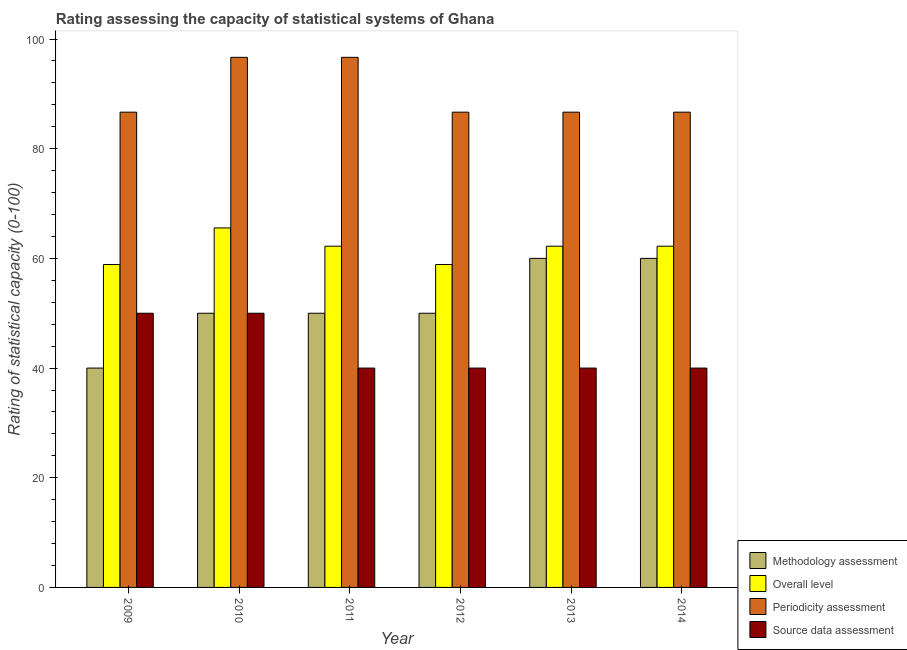How many groups of bars are there?
Make the answer very short. 6. Are the number of bars per tick equal to the number of legend labels?
Give a very brief answer. Yes. How many bars are there on the 2nd tick from the left?
Ensure brevity in your answer.  4. In how many cases, is the number of bars for a given year not equal to the number of legend labels?
Give a very brief answer. 0. What is the source data assessment rating in 2012?
Provide a short and direct response. 40. Across all years, what is the maximum overall level rating?
Provide a short and direct response. 65.56. Across all years, what is the minimum periodicity assessment rating?
Ensure brevity in your answer.  86.67. What is the total source data assessment rating in the graph?
Keep it short and to the point. 260. What is the difference between the methodology assessment rating in 2009 and that in 2011?
Give a very brief answer. -10. What is the difference between the overall level rating in 2013 and the methodology assessment rating in 2009?
Give a very brief answer. 3.33. What is the average periodicity assessment rating per year?
Your answer should be very brief. 90. What is the ratio of the methodology assessment rating in 2009 to that in 2013?
Provide a short and direct response. 0.67. Is the methodology assessment rating in 2009 less than that in 2012?
Ensure brevity in your answer.  Yes. What is the difference between the highest and the second highest source data assessment rating?
Offer a very short reply. 0. What is the difference between the highest and the lowest source data assessment rating?
Your response must be concise. 10. What does the 1st bar from the left in 2012 represents?
Ensure brevity in your answer.  Methodology assessment. What does the 1st bar from the right in 2011 represents?
Offer a very short reply. Source data assessment. Are all the bars in the graph horizontal?
Your response must be concise. No. How many years are there in the graph?
Give a very brief answer. 6. What is the difference between two consecutive major ticks on the Y-axis?
Provide a short and direct response. 20. How many legend labels are there?
Give a very brief answer. 4. What is the title of the graph?
Ensure brevity in your answer.  Rating assessing the capacity of statistical systems of Ghana. What is the label or title of the Y-axis?
Your answer should be compact. Rating of statistical capacity (0-100). What is the Rating of statistical capacity (0-100) in Methodology assessment in 2009?
Give a very brief answer. 40. What is the Rating of statistical capacity (0-100) in Overall level in 2009?
Your response must be concise. 58.89. What is the Rating of statistical capacity (0-100) in Periodicity assessment in 2009?
Provide a succinct answer. 86.67. What is the Rating of statistical capacity (0-100) in Source data assessment in 2009?
Provide a succinct answer. 50. What is the Rating of statistical capacity (0-100) in Methodology assessment in 2010?
Offer a terse response. 50. What is the Rating of statistical capacity (0-100) of Overall level in 2010?
Offer a terse response. 65.56. What is the Rating of statistical capacity (0-100) in Periodicity assessment in 2010?
Provide a succinct answer. 96.67. What is the Rating of statistical capacity (0-100) in Source data assessment in 2010?
Provide a succinct answer. 50. What is the Rating of statistical capacity (0-100) in Overall level in 2011?
Keep it short and to the point. 62.22. What is the Rating of statistical capacity (0-100) of Periodicity assessment in 2011?
Provide a succinct answer. 96.67. What is the Rating of statistical capacity (0-100) of Methodology assessment in 2012?
Make the answer very short. 50. What is the Rating of statistical capacity (0-100) of Overall level in 2012?
Provide a short and direct response. 58.89. What is the Rating of statistical capacity (0-100) of Periodicity assessment in 2012?
Make the answer very short. 86.67. What is the Rating of statistical capacity (0-100) in Source data assessment in 2012?
Give a very brief answer. 40. What is the Rating of statistical capacity (0-100) of Methodology assessment in 2013?
Provide a short and direct response. 60. What is the Rating of statistical capacity (0-100) of Overall level in 2013?
Ensure brevity in your answer.  62.22. What is the Rating of statistical capacity (0-100) of Periodicity assessment in 2013?
Make the answer very short. 86.67. What is the Rating of statistical capacity (0-100) of Source data assessment in 2013?
Provide a succinct answer. 40. What is the Rating of statistical capacity (0-100) in Methodology assessment in 2014?
Your answer should be very brief. 60. What is the Rating of statistical capacity (0-100) in Overall level in 2014?
Your answer should be compact. 62.22. What is the Rating of statistical capacity (0-100) of Periodicity assessment in 2014?
Offer a terse response. 86.67. What is the Rating of statistical capacity (0-100) in Source data assessment in 2014?
Provide a succinct answer. 40. Across all years, what is the maximum Rating of statistical capacity (0-100) in Overall level?
Offer a very short reply. 65.56. Across all years, what is the maximum Rating of statistical capacity (0-100) in Periodicity assessment?
Provide a succinct answer. 96.67. Across all years, what is the maximum Rating of statistical capacity (0-100) of Source data assessment?
Provide a succinct answer. 50. Across all years, what is the minimum Rating of statistical capacity (0-100) in Overall level?
Give a very brief answer. 58.89. Across all years, what is the minimum Rating of statistical capacity (0-100) in Periodicity assessment?
Give a very brief answer. 86.67. What is the total Rating of statistical capacity (0-100) in Methodology assessment in the graph?
Provide a short and direct response. 310. What is the total Rating of statistical capacity (0-100) of Overall level in the graph?
Ensure brevity in your answer.  370. What is the total Rating of statistical capacity (0-100) in Periodicity assessment in the graph?
Make the answer very short. 540. What is the total Rating of statistical capacity (0-100) of Source data assessment in the graph?
Your response must be concise. 260. What is the difference between the Rating of statistical capacity (0-100) of Methodology assessment in 2009 and that in 2010?
Keep it short and to the point. -10. What is the difference between the Rating of statistical capacity (0-100) in Overall level in 2009 and that in 2010?
Give a very brief answer. -6.67. What is the difference between the Rating of statistical capacity (0-100) of Periodicity assessment in 2009 and that in 2010?
Give a very brief answer. -10. What is the difference between the Rating of statistical capacity (0-100) of Source data assessment in 2009 and that in 2010?
Offer a terse response. 0. What is the difference between the Rating of statistical capacity (0-100) in Methodology assessment in 2009 and that in 2011?
Keep it short and to the point. -10. What is the difference between the Rating of statistical capacity (0-100) in Periodicity assessment in 2009 and that in 2012?
Offer a terse response. 0. What is the difference between the Rating of statistical capacity (0-100) of Source data assessment in 2009 and that in 2012?
Provide a short and direct response. 10. What is the difference between the Rating of statistical capacity (0-100) of Overall level in 2009 and that in 2013?
Your answer should be compact. -3.33. What is the difference between the Rating of statistical capacity (0-100) in Source data assessment in 2009 and that in 2013?
Your answer should be very brief. 10. What is the difference between the Rating of statistical capacity (0-100) in Methodology assessment in 2009 and that in 2014?
Keep it short and to the point. -20. What is the difference between the Rating of statistical capacity (0-100) in Overall level in 2009 and that in 2014?
Offer a very short reply. -3.33. What is the difference between the Rating of statistical capacity (0-100) in Source data assessment in 2009 and that in 2014?
Provide a short and direct response. 10. What is the difference between the Rating of statistical capacity (0-100) in Periodicity assessment in 2010 and that in 2011?
Ensure brevity in your answer.  0. What is the difference between the Rating of statistical capacity (0-100) in Overall level in 2010 and that in 2012?
Provide a succinct answer. 6.67. What is the difference between the Rating of statistical capacity (0-100) in Periodicity assessment in 2010 and that in 2012?
Give a very brief answer. 10. What is the difference between the Rating of statistical capacity (0-100) in Methodology assessment in 2010 and that in 2013?
Provide a short and direct response. -10. What is the difference between the Rating of statistical capacity (0-100) in Overall level in 2010 and that in 2013?
Your answer should be very brief. 3.33. What is the difference between the Rating of statistical capacity (0-100) in Methodology assessment in 2010 and that in 2014?
Your answer should be very brief. -10. What is the difference between the Rating of statistical capacity (0-100) in Overall level in 2010 and that in 2014?
Make the answer very short. 3.33. What is the difference between the Rating of statistical capacity (0-100) of Methodology assessment in 2011 and that in 2012?
Make the answer very short. 0. What is the difference between the Rating of statistical capacity (0-100) of Periodicity assessment in 2011 and that in 2012?
Ensure brevity in your answer.  10. What is the difference between the Rating of statistical capacity (0-100) in Source data assessment in 2011 and that in 2012?
Provide a succinct answer. 0. What is the difference between the Rating of statistical capacity (0-100) in Overall level in 2011 and that in 2013?
Offer a very short reply. 0. What is the difference between the Rating of statistical capacity (0-100) in Periodicity assessment in 2011 and that in 2013?
Give a very brief answer. 10. What is the difference between the Rating of statistical capacity (0-100) of Source data assessment in 2011 and that in 2014?
Give a very brief answer. 0. What is the difference between the Rating of statistical capacity (0-100) of Periodicity assessment in 2012 and that in 2013?
Offer a terse response. 0. What is the difference between the Rating of statistical capacity (0-100) in Methodology assessment in 2012 and that in 2014?
Give a very brief answer. -10. What is the difference between the Rating of statistical capacity (0-100) in Overall level in 2012 and that in 2014?
Give a very brief answer. -3.33. What is the difference between the Rating of statistical capacity (0-100) in Source data assessment in 2012 and that in 2014?
Provide a short and direct response. 0. What is the difference between the Rating of statistical capacity (0-100) in Periodicity assessment in 2013 and that in 2014?
Make the answer very short. 0. What is the difference between the Rating of statistical capacity (0-100) of Methodology assessment in 2009 and the Rating of statistical capacity (0-100) of Overall level in 2010?
Ensure brevity in your answer.  -25.56. What is the difference between the Rating of statistical capacity (0-100) of Methodology assessment in 2009 and the Rating of statistical capacity (0-100) of Periodicity assessment in 2010?
Keep it short and to the point. -56.67. What is the difference between the Rating of statistical capacity (0-100) in Overall level in 2009 and the Rating of statistical capacity (0-100) in Periodicity assessment in 2010?
Your answer should be compact. -37.78. What is the difference between the Rating of statistical capacity (0-100) in Overall level in 2009 and the Rating of statistical capacity (0-100) in Source data assessment in 2010?
Your answer should be compact. 8.89. What is the difference between the Rating of statistical capacity (0-100) of Periodicity assessment in 2009 and the Rating of statistical capacity (0-100) of Source data assessment in 2010?
Make the answer very short. 36.67. What is the difference between the Rating of statistical capacity (0-100) of Methodology assessment in 2009 and the Rating of statistical capacity (0-100) of Overall level in 2011?
Give a very brief answer. -22.22. What is the difference between the Rating of statistical capacity (0-100) in Methodology assessment in 2009 and the Rating of statistical capacity (0-100) in Periodicity assessment in 2011?
Your response must be concise. -56.67. What is the difference between the Rating of statistical capacity (0-100) in Overall level in 2009 and the Rating of statistical capacity (0-100) in Periodicity assessment in 2011?
Give a very brief answer. -37.78. What is the difference between the Rating of statistical capacity (0-100) in Overall level in 2009 and the Rating of statistical capacity (0-100) in Source data assessment in 2011?
Give a very brief answer. 18.89. What is the difference between the Rating of statistical capacity (0-100) of Periodicity assessment in 2009 and the Rating of statistical capacity (0-100) of Source data assessment in 2011?
Keep it short and to the point. 46.67. What is the difference between the Rating of statistical capacity (0-100) in Methodology assessment in 2009 and the Rating of statistical capacity (0-100) in Overall level in 2012?
Your answer should be compact. -18.89. What is the difference between the Rating of statistical capacity (0-100) of Methodology assessment in 2009 and the Rating of statistical capacity (0-100) of Periodicity assessment in 2012?
Ensure brevity in your answer.  -46.67. What is the difference between the Rating of statistical capacity (0-100) of Overall level in 2009 and the Rating of statistical capacity (0-100) of Periodicity assessment in 2012?
Make the answer very short. -27.78. What is the difference between the Rating of statistical capacity (0-100) of Overall level in 2009 and the Rating of statistical capacity (0-100) of Source data assessment in 2012?
Keep it short and to the point. 18.89. What is the difference between the Rating of statistical capacity (0-100) in Periodicity assessment in 2009 and the Rating of statistical capacity (0-100) in Source data assessment in 2012?
Provide a short and direct response. 46.67. What is the difference between the Rating of statistical capacity (0-100) of Methodology assessment in 2009 and the Rating of statistical capacity (0-100) of Overall level in 2013?
Make the answer very short. -22.22. What is the difference between the Rating of statistical capacity (0-100) of Methodology assessment in 2009 and the Rating of statistical capacity (0-100) of Periodicity assessment in 2013?
Keep it short and to the point. -46.67. What is the difference between the Rating of statistical capacity (0-100) in Overall level in 2009 and the Rating of statistical capacity (0-100) in Periodicity assessment in 2013?
Your answer should be compact. -27.78. What is the difference between the Rating of statistical capacity (0-100) in Overall level in 2009 and the Rating of statistical capacity (0-100) in Source data assessment in 2013?
Your answer should be very brief. 18.89. What is the difference between the Rating of statistical capacity (0-100) of Periodicity assessment in 2009 and the Rating of statistical capacity (0-100) of Source data assessment in 2013?
Your response must be concise. 46.67. What is the difference between the Rating of statistical capacity (0-100) of Methodology assessment in 2009 and the Rating of statistical capacity (0-100) of Overall level in 2014?
Offer a very short reply. -22.22. What is the difference between the Rating of statistical capacity (0-100) of Methodology assessment in 2009 and the Rating of statistical capacity (0-100) of Periodicity assessment in 2014?
Provide a short and direct response. -46.67. What is the difference between the Rating of statistical capacity (0-100) of Methodology assessment in 2009 and the Rating of statistical capacity (0-100) of Source data assessment in 2014?
Your answer should be compact. 0. What is the difference between the Rating of statistical capacity (0-100) in Overall level in 2009 and the Rating of statistical capacity (0-100) in Periodicity assessment in 2014?
Your answer should be very brief. -27.78. What is the difference between the Rating of statistical capacity (0-100) in Overall level in 2009 and the Rating of statistical capacity (0-100) in Source data assessment in 2014?
Provide a short and direct response. 18.89. What is the difference between the Rating of statistical capacity (0-100) of Periodicity assessment in 2009 and the Rating of statistical capacity (0-100) of Source data assessment in 2014?
Provide a succinct answer. 46.67. What is the difference between the Rating of statistical capacity (0-100) in Methodology assessment in 2010 and the Rating of statistical capacity (0-100) in Overall level in 2011?
Keep it short and to the point. -12.22. What is the difference between the Rating of statistical capacity (0-100) of Methodology assessment in 2010 and the Rating of statistical capacity (0-100) of Periodicity assessment in 2011?
Your answer should be compact. -46.67. What is the difference between the Rating of statistical capacity (0-100) in Overall level in 2010 and the Rating of statistical capacity (0-100) in Periodicity assessment in 2011?
Your answer should be compact. -31.11. What is the difference between the Rating of statistical capacity (0-100) in Overall level in 2010 and the Rating of statistical capacity (0-100) in Source data assessment in 2011?
Offer a very short reply. 25.56. What is the difference between the Rating of statistical capacity (0-100) in Periodicity assessment in 2010 and the Rating of statistical capacity (0-100) in Source data assessment in 2011?
Your answer should be very brief. 56.67. What is the difference between the Rating of statistical capacity (0-100) in Methodology assessment in 2010 and the Rating of statistical capacity (0-100) in Overall level in 2012?
Keep it short and to the point. -8.89. What is the difference between the Rating of statistical capacity (0-100) of Methodology assessment in 2010 and the Rating of statistical capacity (0-100) of Periodicity assessment in 2012?
Give a very brief answer. -36.67. What is the difference between the Rating of statistical capacity (0-100) in Methodology assessment in 2010 and the Rating of statistical capacity (0-100) in Source data assessment in 2012?
Your response must be concise. 10. What is the difference between the Rating of statistical capacity (0-100) in Overall level in 2010 and the Rating of statistical capacity (0-100) in Periodicity assessment in 2012?
Provide a short and direct response. -21.11. What is the difference between the Rating of statistical capacity (0-100) of Overall level in 2010 and the Rating of statistical capacity (0-100) of Source data assessment in 2012?
Ensure brevity in your answer.  25.56. What is the difference between the Rating of statistical capacity (0-100) in Periodicity assessment in 2010 and the Rating of statistical capacity (0-100) in Source data assessment in 2012?
Provide a succinct answer. 56.67. What is the difference between the Rating of statistical capacity (0-100) in Methodology assessment in 2010 and the Rating of statistical capacity (0-100) in Overall level in 2013?
Give a very brief answer. -12.22. What is the difference between the Rating of statistical capacity (0-100) of Methodology assessment in 2010 and the Rating of statistical capacity (0-100) of Periodicity assessment in 2013?
Give a very brief answer. -36.67. What is the difference between the Rating of statistical capacity (0-100) in Overall level in 2010 and the Rating of statistical capacity (0-100) in Periodicity assessment in 2013?
Give a very brief answer. -21.11. What is the difference between the Rating of statistical capacity (0-100) of Overall level in 2010 and the Rating of statistical capacity (0-100) of Source data assessment in 2013?
Your answer should be compact. 25.56. What is the difference between the Rating of statistical capacity (0-100) of Periodicity assessment in 2010 and the Rating of statistical capacity (0-100) of Source data assessment in 2013?
Your response must be concise. 56.67. What is the difference between the Rating of statistical capacity (0-100) in Methodology assessment in 2010 and the Rating of statistical capacity (0-100) in Overall level in 2014?
Keep it short and to the point. -12.22. What is the difference between the Rating of statistical capacity (0-100) in Methodology assessment in 2010 and the Rating of statistical capacity (0-100) in Periodicity assessment in 2014?
Your answer should be compact. -36.67. What is the difference between the Rating of statistical capacity (0-100) of Overall level in 2010 and the Rating of statistical capacity (0-100) of Periodicity assessment in 2014?
Make the answer very short. -21.11. What is the difference between the Rating of statistical capacity (0-100) in Overall level in 2010 and the Rating of statistical capacity (0-100) in Source data assessment in 2014?
Offer a very short reply. 25.56. What is the difference between the Rating of statistical capacity (0-100) of Periodicity assessment in 2010 and the Rating of statistical capacity (0-100) of Source data assessment in 2014?
Your response must be concise. 56.67. What is the difference between the Rating of statistical capacity (0-100) of Methodology assessment in 2011 and the Rating of statistical capacity (0-100) of Overall level in 2012?
Give a very brief answer. -8.89. What is the difference between the Rating of statistical capacity (0-100) in Methodology assessment in 2011 and the Rating of statistical capacity (0-100) in Periodicity assessment in 2012?
Provide a short and direct response. -36.67. What is the difference between the Rating of statistical capacity (0-100) in Methodology assessment in 2011 and the Rating of statistical capacity (0-100) in Source data assessment in 2012?
Offer a very short reply. 10. What is the difference between the Rating of statistical capacity (0-100) of Overall level in 2011 and the Rating of statistical capacity (0-100) of Periodicity assessment in 2012?
Your response must be concise. -24.44. What is the difference between the Rating of statistical capacity (0-100) of Overall level in 2011 and the Rating of statistical capacity (0-100) of Source data assessment in 2012?
Offer a very short reply. 22.22. What is the difference between the Rating of statistical capacity (0-100) of Periodicity assessment in 2011 and the Rating of statistical capacity (0-100) of Source data assessment in 2012?
Ensure brevity in your answer.  56.67. What is the difference between the Rating of statistical capacity (0-100) of Methodology assessment in 2011 and the Rating of statistical capacity (0-100) of Overall level in 2013?
Offer a very short reply. -12.22. What is the difference between the Rating of statistical capacity (0-100) of Methodology assessment in 2011 and the Rating of statistical capacity (0-100) of Periodicity assessment in 2013?
Your response must be concise. -36.67. What is the difference between the Rating of statistical capacity (0-100) of Overall level in 2011 and the Rating of statistical capacity (0-100) of Periodicity assessment in 2013?
Give a very brief answer. -24.44. What is the difference between the Rating of statistical capacity (0-100) of Overall level in 2011 and the Rating of statistical capacity (0-100) of Source data assessment in 2013?
Offer a terse response. 22.22. What is the difference between the Rating of statistical capacity (0-100) in Periodicity assessment in 2011 and the Rating of statistical capacity (0-100) in Source data assessment in 2013?
Provide a short and direct response. 56.67. What is the difference between the Rating of statistical capacity (0-100) in Methodology assessment in 2011 and the Rating of statistical capacity (0-100) in Overall level in 2014?
Make the answer very short. -12.22. What is the difference between the Rating of statistical capacity (0-100) of Methodology assessment in 2011 and the Rating of statistical capacity (0-100) of Periodicity assessment in 2014?
Your response must be concise. -36.67. What is the difference between the Rating of statistical capacity (0-100) of Overall level in 2011 and the Rating of statistical capacity (0-100) of Periodicity assessment in 2014?
Make the answer very short. -24.44. What is the difference between the Rating of statistical capacity (0-100) of Overall level in 2011 and the Rating of statistical capacity (0-100) of Source data assessment in 2014?
Your answer should be very brief. 22.22. What is the difference between the Rating of statistical capacity (0-100) in Periodicity assessment in 2011 and the Rating of statistical capacity (0-100) in Source data assessment in 2014?
Your answer should be very brief. 56.67. What is the difference between the Rating of statistical capacity (0-100) in Methodology assessment in 2012 and the Rating of statistical capacity (0-100) in Overall level in 2013?
Keep it short and to the point. -12.22. What is the difference between the Rating of statistical capacity (0-100) of Methodology assessment in 2012 and the Rating of statistical capacity (0-100) of Periodicity assessment in 2013?
Offer a very short reply. -36.67. What is the difference between the Rating of statistical capacity (0-100) in Methodology assessment in 2012 and the Rating of statistical capacity (0-100) in Source data assessment in 2013?
Your response must be concise. 10. What is the difference between the Rating of statistical capacity (0-100) of Overall level in 2012 and the Rating of statistical capacity (0-100) of Periodicity assessment in 2013?
Make the answer very short. -27.78. What is the difference between the Rating of statistical capacity (0-100) in Overall level in 2012 and the Rating of statistical capacity (0-100) in Source data assessment in 2013?
Keep it short and to the point. 18.89. What is the difference between the Rating of statistical capacity (0-100) of Periodicity assessment in 2012 and the Rating of statistical capacity (0-100) of Source data assessment in 2013?
Your answer should be very brief. 46.67. What is the difference between the Rating of statistical capacity (0-100) of Methodology assessment in 2012 and the Rating of statistical capacity (0-100) of Overall level in 2014?
Your answer should be compact. -12.22. What is the difference between the Rating of statistical capacity (0-100) of Methodology assessment in 2012 and the Rating of statistical capacity (0-100) of Periodicity assessment in 2014?
Offer a terse response. -36.67. What is the difference between the Rating of statistical capacity (0-100) of Overall level in 2012 and the Rating of statistical capacity (0-100) of Periodicity assessment in 2014?
Provide a short and direct response. -27.78. What is the difference between the Rating of statistical capacity (0-100) in Overall level in 2012 and the Rating of statistical capacity (0-100) in Source data assessment in 2014?
Your answer should be very brief. 18.89. What is the difference between the Rating of statistical capacity (0-100) in Periodicity assessment in 2012 and the Rating of statistical capacity (0-100) in Source data assessment in 2014?
Your answer should be compact. 46.67. What is the difference between the Rating of statistical capacity (0-100) of Methodology assessment in 2013 and the Rating of statistical capacity (0-100) of Overall level in 2014?
Your answer should be compact. -2.22. What is the difference between the Rating of statistical capacity (0-100) of Methodology assessment in 2013 and the Rating of statistical capacity (0-100) of Periodicity assessment in 2014?
Your answer should be compact. -26.67. What is the difference between the Rating of statistical capacity (0-100) of Overall level in 2013 and the Rating of statistical capacity (0-100) of Periodicity assessment in 2014?
Keep it short and to the point. -24.44. What is the difference between the Rating of statistical capacity (0-100) in Overall level in 2013 and the Rating of statistical capacity (0-100) in Source data assessment in 2014?
Offer a very short reply. 22.22. What is the difference between the Rating of statistical capacity (0-100) in Periodicity assessment in 2013 and the Rating of statistical capacity (0-100) in Source data assessment in 2014?
Your response must be concise. 46.67. What is the average Rating of statistical capacity (0-100) of Methodology assessment per year?
Make the answer very short. 51.67. What is the average Rating of statistical capacity (0-100) of Overall level per year?
Your answer should be very brief. 61.67. What is the average Rating of statistical capacity (0-100) in Periodicity assessment per year?
Your response must be concise. 90. What is the average Rating of statistical capacity (0-100) in Source data assessment per year?
Make the answer very short. 43.33. In the year 2009, what is the difference between the Rating of statistical capacity (0-100) in Methodology assessment and Rating of statistical capacity (0-100) in Overall level?
Offer a terse response. -18.89. In the year 2009, what is the difference between the Rating of statistical capacity (0-100) in Methodology assessment and Rating of statistical capacity (0-100) in Periodicity assessment?
Ensure brevity in your answer.  -46.67. In the year 2009, what is the difference between the Rating of statistical capacity (0-100) of Methodology assessment and Rating of statistical capacity (0-100) of Source data assessment?
Provide a succinct answer. -10. In the year 2009, what is the difference between the Rating of statistical capacity (0-100) of Overall level and Rating of statistical capacity (0-100) of Periodicity assessment?
Ensure brevity in your answer.  -27.78. In the year 2009, what is the difference between the Rating of statistical capacity (0-100) of Overall level and Rating of statistical capacity (0-100) of Source data assessment?
Make the answer very short. 8.89. In the year 2009, what is the difference between the Rating of statistical capacity (0-100) of Periodicity assessment and Rating of statistical capacity (0-100) of Source data assessment?
Offer a terse response. 36.67. In the year 2010, what is the difference between the Rating of statistical capacity (0-100) of Methodology assessment and Rating of statistical capacity (0-100) of Overall level?
Give a very brief answer. -15.56. In the year 2010, what is the difference between the Rating of statistical capacity (0-100) of Methodology assessment and Rating of statistical capacity (0-100) of Periodicity assessment?
Keep it short and to the point. -46.67. In the year 2010, what is the difference between the Rating of statistical capacity (0-100) of Overall level and Rating of statistical capacity (0-100) of Periodicity assessment?
Your answer should be compact. -31.11. In the year 2010, what is the difference between the Rating of statistical capacity (0-100) in Overall level and Rating of statistical capacity (0-100) in Source data assessment?
Your response must be concise. 15.56. In the year 2010, what is the difference between the Rating of statistical capacity (0-100) of Periodicity assessment and Rating of statistical capacity (0-100) of Source data assessment?
Ensure brevity in your answer.  46.67. In the year 2011, what is the difference between the Rating of statistical capacity (0-100) of Methodology assessment and Rating of statistical capacity (0-100) of Overall level?
Your response must be concise. -12.22. In the year 2011, what is the difference between the Rating of statistical capacity (0-100) of Methodology assessment and Rating of statistical capacity (0-100) of Periodicity assessment?
Keep it short and to the point. -46.67. In the year 2011, what is the difference between the Rating of statistical capacity (0-100) in Overall level and Rating of statistical capacity (0-100) in Periodicity assessment?
Offer a very short reply. -34.44. In the year 2011, what is the difference between the Rating of statistical capacity (0-100) of Overall level and Rating of statistical capacity (0-100) of Source data assessment?
Your response must be concise. 22.22. In the year 2011, what is the difference between the Rating of statistical capacity (0-100) in Periodicity assessment and Rating of statistical capacity (0-100) in Source data assessment?
Make the answer very short. 56.67. In the year 2012, what is the difference between the Rating of statistical capacity (0-100) in Methodology assessment and Rating of statistical capacity (0-100) in Overall level?
Offer a very short reply. -8.89. In the year 2012, what is the difference between the Rating of statistical capacity (0-100) in Methodology assessment and Rating of statistical capacity (0-100) in Periodicity assessment?
Provide a short and direct response. -36.67. In the year 2012, what is the difference between the Rating of statistical capacity (0-100) of Overall level and Rating of statistical capacity (0-100) of Periodicity assessment?
Provide a succinct answer. -27.78. In the year 2012, what is the difference between the Rating of statistical capacity (0-100) in Overall level and Rating of statistical capacity (0-100) in Source data assessment?
Ensure brevity in your answer.  18.89. In the year 2012, what is the difference between the Rating of statistical capacity (0-100) of Periodicity assessment and Rating of statistical capacity (0-100) of Source data assessment?
Offer a terse response. 46.67. In the year 2013, what is the difference between the Rating of statistical capacity (0-100) of Methodology assessment and Rating of statistical capacity (0-100) of Overall level?
Provide a succinct answer. -2.22. In the year 2013, what is the difference between the Rating of statistical capacity (0-100) in Methodology assessment and Rating of statistical capacity (0-100) in Periodicity assessment?
Make the answer very short. -26.67. In the year 2013, what is the difference between the Rating of statistical capacity (0-100) in Methodology assessment and Rating of statistical capacity (0-100) in Source data assessment?
Make the answer very short. 20. In the year 2013, what is the difference between the Rating of statistical capacity (0-100) of Overall level and Rating of statistical capacity (0-100) of Periodicity assessment?
Offer a terse response. -24.44. In the year 2013, what is the difference between the Rating of statistical capacity (0-100) of Overall level and Rating of statistical capacity (0-100) of Source data assessment?
Keep it short and to the point. 22.22. In the year 2013, what is the difference between the Rating of statistical capacity (0-100) in Periodicity assessment and Rating of statistical capacity (0-100) in Source data assessment?
Provide a succinct answer. 46.67. In the year 2014, what is the difference between the Rating of statistical capacity (0-100) of Methodology assessment and Rating of statistical capacity (0-100) of Overall level?
Offer a terse response. -2.22. In the year 2014, what is the difference between the Rating of statistical capacity (0-100) in Methodology assessment and Rating of statistical capacity (0-100) in Periodicity assessment?
Give a very brief answer. -26.67. In the year 2014, what is the difference between the Rating of statistical capacity (0-100) in Overall level and Rating of statistical capacity (0-100) in Periodicity assessment?
Give a very brief answer. -24.44. In the year 2014, what is the difference between the Rating of statistical capacity (0-100) of Overall level and Rating of statistical capacity (0-100) of Source data assessment?
Your response must be concise. 22.22. In the year 2014, what is the difference between the Rating of statistical capacity (0-100) of Periodicity assessment and Rating of statistical capacity (0-100) of Source data assessment?
Your answer should be compact. 46.67. What is the ratio of the Rating of statistical capacity (0-100) in Overall level in 2009 to that in 2010?
Your response must be concise. 0.9. What is the ratio of the Rating of statistical capacity (0-100) in Periodicity assessment in 2009 to that in 2010?
Your answer should be compact. 0.9. What is the ratio of the Rating of statistical capacity (0-100) of Overall level in 2009 to that in 2011?
Provide a succinct answer. 0.95. What is the ratio of the Rating of statistical capacity (0-100) of Periodicity assessment in 2009 to that in 2011?
Offer a terse response. 0.9. What is the ratio of the Rating of statistical capacity (0-100) of Source data assessment in 2009 to that in 2011?
Offer a terse response. 1.25. What is the ratio of the Rating of statistical capacity (0-100) in Overall level in 2009 to that in 2013?
Your answer should be very brief. 0.95. What is the ratio of the Rating of statistical capacity (0-100) of Source data assessment in 2009 to that in 2013?
Offer a terse response. 1.25. What is the ratio of the Rating of statistical capacity (0-100) of Methodology assessment in 2009 to that in 2014?
Ensure brevity in your answer.  0.67. What is the ratio of the Rating of statistical capacity (0-100) of Overall level in 2009 to that in 2014?
Ensure brevity in your answer.  0.95. What is the ratio of the Rating of statistical capacity (0-100) of Overall level in 2010 to that in 2011?
Your answer should be compact. 1.05. What is the ratio of the Rating of statistical capacity (0-100) of Methodology assessment in 2010 to that in 2012?
Give a very brief answer. 1. What is the ratio of the Rating of statistical capacity (0-100) in Overall level in 2010 to that in 2012?
Offer a very short reply. 1.11. What is the ratio of the Rating of statistical capacity (0-100) of Periodicity assessment in 2010 to that in 2012?
Make the answer very short. 1.12. What is the ratio of the Rating of statistical capacity (0-100) in Source data assessment in 2010 to that in 2012?
Your answer should be very brief. 1.25. What is the ratio of the Rating of statistical capacity (0-100) in Overall level in 2010 to that in 2013?
Offer a terse response. 1.05. What is the ratio of the Rating of statistical capacity (0-100) in Periodicity assessment in 2010 to that in 2013?
Keep it short and to the point. 1.12. What is the ratio of the Rating of statistical capacity (0-100) of Source data assessment in 2010 to that in 2013?
Keep it short and to the point. 1.25. What is the ratio of the Rating of statistical capacity (0-100) of Methodology assessment in 2010 to that in 2014?
Offer a very short reply. 0.83. What is the ratio of the Rating of statistical capacity (0-100) of Overall level in 2010 to that in 2014?
Ensure brevity in your answer.  1.05. What is the ratio of the Rating of statistical capacity (0-100) in Periodicity assessment in 2010 to that in 2014?
Provide a short and direct response. 1.12. What is the ratio of the Rating of statistical capacity (0-100) in Methodology assessment in 2011 to that in 2012?
Ensure brevity in your answer.  1. What is the ratio of the Rating of statistical capacity (0-100) in Overall level in 2011 to that in 2012?
Your answer should be compact. 1.06. What is the ratio of the Rating of statistical capacity (0-100) of Periodicity assessment in 2011 to that in 2012?
Your answer should be very brief. 1.12. What is the ratio of the Rating of statistical capacity (0-100) of Source data assessment in 2011 to that in 2012?
Ensure brevity in your answer.  1. What is the ratio of the Rating of statistical capacity (0-100) of Overall level in 2011 to that in 2013?
Ensure brevity in your answer.  1. What is the ratio of the Rating of statistical capacity (0-100) in Periodicity assessment in 2011 to that in 2013?
Offer a very short reply. 1.12. What is the ratio of the Rating of statistical capacity (0-100) of Source data assessment in 2011 to that in 2013?
Your answer should be compact. 1. What is the ratio of the Rating of statistical capacity (0-100) of Overall level in 2011 to that in 2014?
Make the answer very short. 1. What is the ratio of the Rating of statistical capacity (0-100) of Periodicity assessment in 2011 to that in 2014?
Your response must be concise. 1.12. What is the ratio of the Rating of statistical capacity (0-100) of Source data assessment in 2011 to that in 2014?
Your answer should be very brief. 1. What is the ratio of the Rating of statistical capacity (0-100) in Methodology assessment in 2012 to that in 2013?
Your response must be concise. 0.83. What is the ratio of the Rating of statistical capacity (0-100) of Overall level in 2012 to that in 2013?
Ensure brevity in your answer.  0.95. What is the ratio of the Rating of statistical capacity (0-100) of Periodicity assessment in 2012 to that in 2013?
Make the answer very short. 1. What is the ratio of the Rating of statistical capacity (0-100) of Source data assessment in 2012 to that in 2013?
Provide a short and direct response. 1. What is the ratio of the Rating of statistical capacity (0-100) of Overall level in 2012 to that in 2014?
Offer a very short reply. 0.95. What is the ratio of the Rating of statistical capacity (0-100) of Periodicity assessment in 2012 to that in 2014?
Your answer should be very brief. 1. What is the ratio of the Rating of statistical capacity (0-100) of Source data assessment in 2012 to that in 2014?
Offer a terse response. 1. What is the ratio of the Rating of statistical capacity (0-100) of Methodology assessment in 2013 to that in 2014?
Your response must be concise. 1. What is the ratio of the Rating of statistical capacity (0-100) of Overall level in 2013 to that in 2014?
Ensure brevity in your answer.  1. What is the ratio of the Rating of statistical capacity (0-100) in Source data assessment in 2013 to that in 2014?
Ensure brevity in your answer.  1. What is the difference between the highest and the second highest Rating of statistical capacity (0-100) of Methodology assessment?
Give a very brief answer. 0. What is the difference between the highest and the second highest Rating of statistical capacity (0-100) of Overall level?
Your response must be concise. 3.33. What is the difference between the highest and the second highest Rating of statistical capacity (0-100) of Periodicity assessment?
Provide a succinct answer. 0. What is the difference between the highest and the second highest Rating of statistical capacity (0-100) in Source data assessment?
Keep it short and to the point. 0. What is the difference between the highest and the lowest Rating of statistical capacity (0-100) in Source data assessment?
Offer a terse response. 10. 